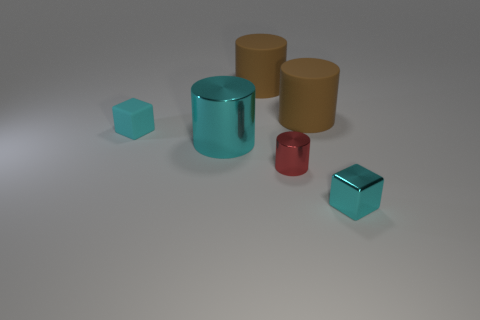How do the properties of the materials of these objects affect the way light interacts with their surfaces? The differing material properties, such as the rough texture of the rubber versus the polished surface of the metal, cause light to interact distinctly with each object. The rubber's matte finish diffuses light, softening reflections, whereas the metal's smooth surface reflects light sharply, creating clear highlights and defined reflections. 